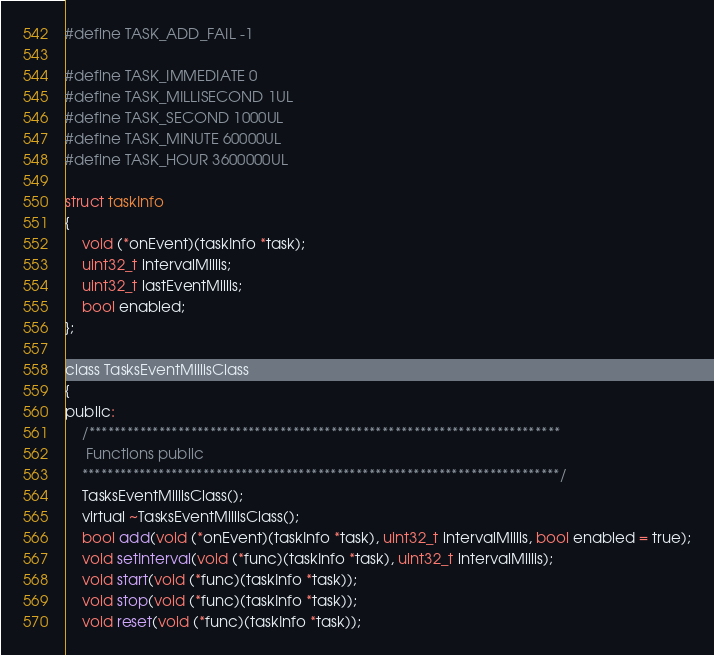<code> <loc_0><loc_0><loc_500><loc_500><_C_>
#define TASK_ADD_FAIL -1

#define TASK_IMMEDIATE 0
#define TASK_MILLISECOND 1UL
#define TASK_SECOND 1000UL
#define TASK_MINUTE 60000UL
#define TASK_HOUR 3600000UL

struct taskInfo
{
	void (*onEvent)(taskInfo *task);
	uint32_t intervalMillis;
	uint32_t lastEventMillis;
	bool enabled;
};

class TasksEventMillisClass
{
public:
	/**************************************************************************
	 Functions public
  	***************************************************************************/
	TasksEventMillisClass();
	virtual ~TasksEventMillisClass();
	bool add(void (*onEvent)(taskInfo *task), uint32_t intervalMillis, bool enabled = true);
	void setInterval(void (*func)(taskInfo *task), uint32_t intervalMillis);
	void start(void (*func)(taskInfo *task));
	void stop(void (*func)(taskInfo *task));
	void reset(void (*func)(taskInfo *task));</code> 